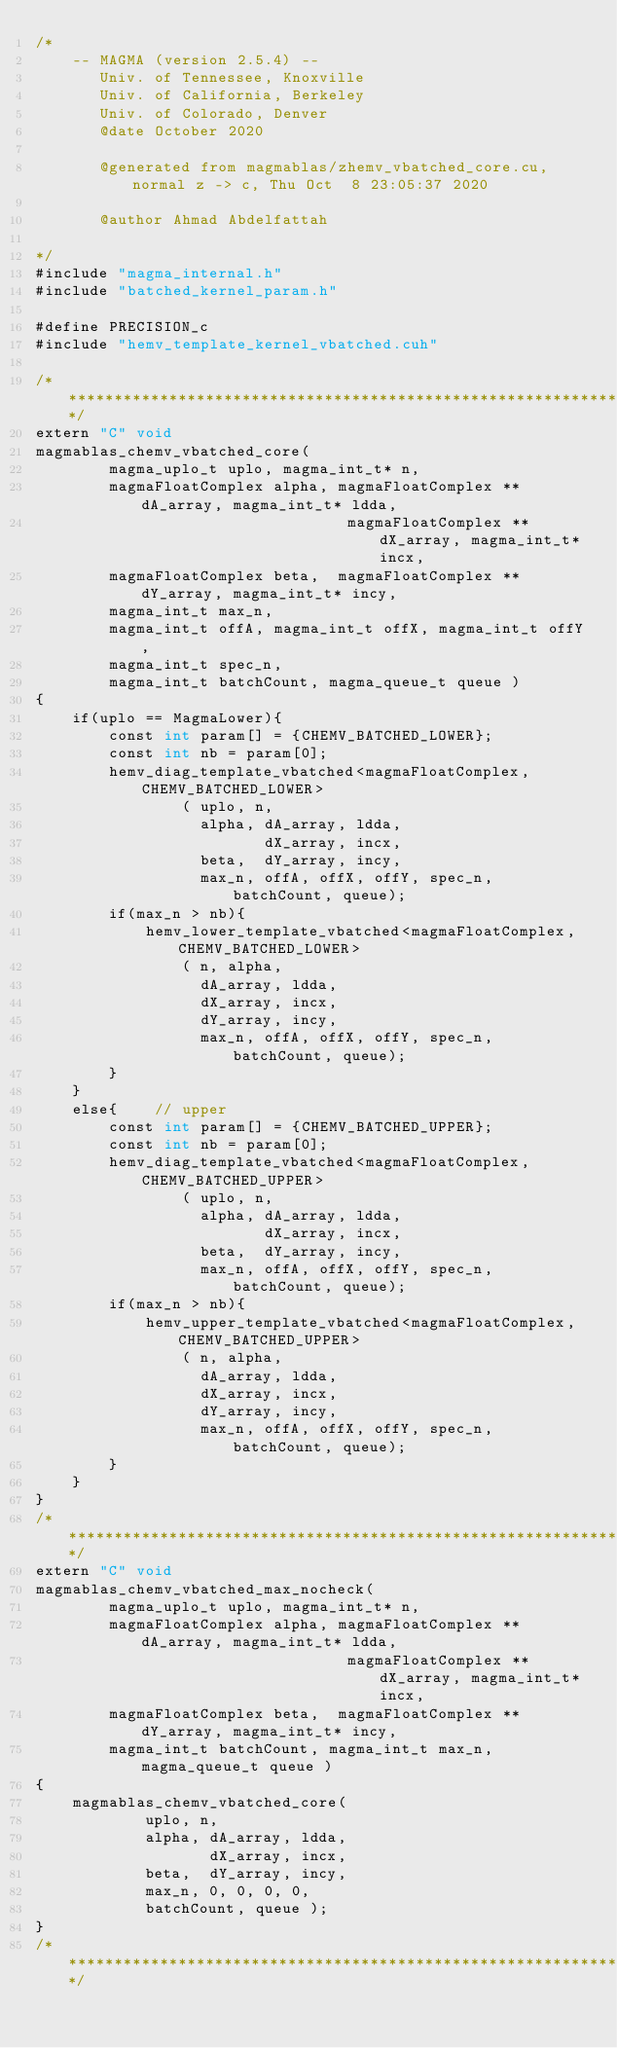<code> <loc_0><loc_0><loc_500><loc_500><_Cuda_>/*
    -- MAGMA (version 2.5.4) --
       Univ. of Tennessee, Knoxville
       Univ. of California, Berkeley
       Univ. of Colorado, Denver
       @date October 2020

       @generated from magmablas/zhemv_vbatched_core.cu, normal z -> c, Thu Oct  8 23:05:37 2020

       @author Ahmad Abdelfattah
       
*/
#include "magma_internal.h"
#include "batched_kernel_param.h"

#define PRECISION_c
#include "hemv_template_kernel_vbatched.cuh"

/******************************************************************************/
extern "C" void 
magmablas_chemv_vbatched_core(
        magma_uplo_t uplo, magma_int_t* n, 
        magmaFloatComplex alpha, magmaFloatComplex **dA_array, magma_int_t* ldda,
                                  magmaFloatComplex **dX_array, magma_int_t* incx,
        magmaFloatComplex beta,  magmaFloatComplex **dY_array, magma_int_t* incy,
        magma_int_t max_n, 
        magma_int_t offA, magma_int_t offX, magma_int_t offY, 
        magma_int_t spec_n, 
        magma_int_t batchCount, magma_queue_t queue )
{
    if(uplo == MagmaLower){
        const int param[] = {CHEMV_BATCHED_LOWER};
        const int nb = param[0];
        hemv_diag_template_vbatched<magmaFloatComplex, CHEMV_BATCHED_LOWER>
                ( uplo, n, 
                  alpha, dA_array, ldda, 
                         dX_array, incx, 
                  beta,  dY_array, incy, 
                  max_n, offA, offX, offY, spec_n, batchCount, queue);
        if(max_n > nb){
            hemv_lower_template_vbatched<magmaFloatComplex, CHEMV_BATCHED_LOWER>
                ( n, alpha, 
                  dA_array, ldda, 
                  dX_array, incx, 
                  dY_array, incy, 
                  max_n, offA, offX, offY, spec_n, batchCount, queue);
        }
    }
    else{    // upper
        const int param[] = {CHEMV_BATCHED_UPPER};
        const int nb = param[0];
        hemv_diag_template_vbatched<magmaFloatComplex, CHEMV_BATCHED_UPPER>
                ( uplo, n, 
                  alpha, dA_array, ldda, 
                         dX_array, incx, 
                  beta,  dY_array, incy, 
                  max_n, offA, offX, offY, spec_n, batchCount, queue);
        if(max_n > nb){
            hemv_upper_template_vbatched<magmaFloatComplex, CHEMV_BATCHED_UPPER>
                ( n, alpha, 
                  dA_array, ldda, 
                  dX_array, incx, 
                  dY_array, incy, 
                  max_n, offA, offX, offY, spec_n, batchCount, queue);
        }
    }
}
/******************************************************************************/
extern "C" void 
magmablas_chemv_vbatched_max_nocheck(
        magma_uplo_t uplo, magma_int_t* n, 
        magmaFloatComplex alpha, magmaFloatComplex **dA_array, magma_int_t* ldda,
                                  magmaFloatComplex **dX_array, magma_int_t* incx,
        magmaFloatComplex beta,  magmaFloatComplex **dY_array, magma_int_t* incy, 
        magma_int_t batchCount, magma_int_t max_n, magma_queue_t queue )
{
    magmablas_chemv_vbatched_core( 
            uplo, n, 
            alpha, dA_array, ldda, 
                   dX_array, incx,
            beta,  dY_array, incy,  
            max_n, 0, 0, 0, 0, 
            batchCount, queue );
}
/******************************************************************************/
</code> 